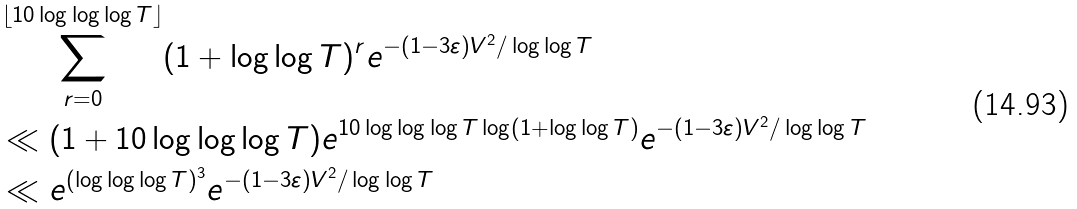Convert formula to latex. <formula><loc_0><loc_0><loc_500><loc_500>& \sum _ { r = 0 } ^ { \lfloor 1 0 \log \log \log T \rfloor } ( 1 + \log \log T ) ^ { r } e ^ { - ( 1 - 3 \varepsilon ) V ^ { 2 } / \log \log T } \\ & \ll ( 1 + 1 0 \log \log \log T ) e ^ { 1 0 \log \log \log T \log ( 1 + \log \log T ) } e ^ { - ( 1 - 3 \varepsilon ) V ^ { 2 } / \log \log T } \\ & \ll e ^ { ( \log \log \log T ) ^ { 3 } } e ^ { - ( 1 - 3 \varepsilon ) V ^ { 2 } / \log \log T }</formula> 